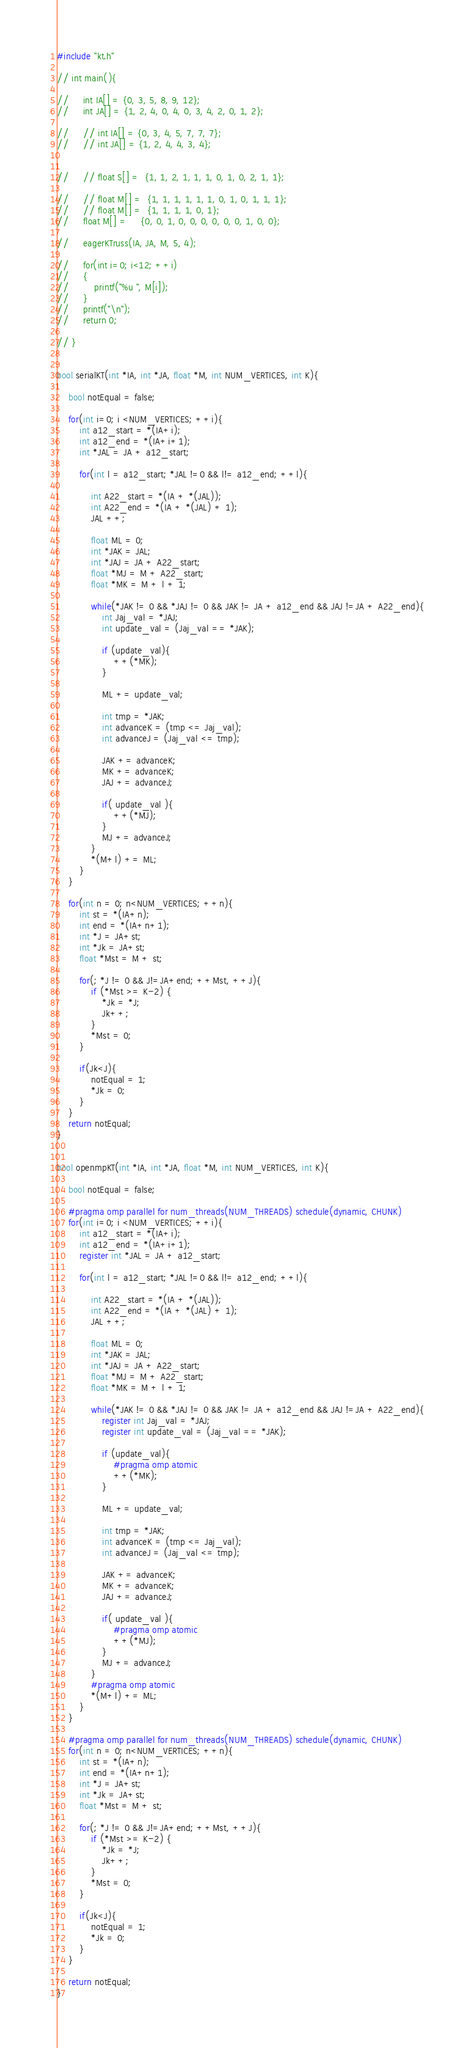Convert code to text. <code><loc_0><loc_0><loc_500><loc_500><_Cuda_>#include "kt.h"

// int main(){

//     int IA[] = {0, 3, 5, 8, 9, 12};
//     int JA[] = {1, 2, 4, 0, 4, 0, 3, 4, 2, 0, 1, 2};

//     // int IA[] = {0, 3, 4, 5, 7, 7, 7};
//     // int JA[] = {1, 2, 4, 4, 3, 4};


//     // float S[] =  {1, 1, 2, 1, 1, 1, 0, 1, 0, 2, 1, 1};

//     // float M[] =  {1, 1, 1, 1, 1, 1, 0, 1, 0, 1, 1, 1};
//     // float M[] =  {1, 1, 1, 1, 0, 1};
//     float M[] =     {0, 0, 1, 0, 0, 0, 0, 0, 0, 1, 0, 0};

//     eagerKTruss(IA, JA, M, 5, 4);

//     for(int i=0; i<12; ++i)
//     {
//         printf("%u ", M[i]);
//     }
//     printf("\n");
//     return 0;

// }


bool serialKT(int *IA, int *JA, float *M, int NUM_VERTICES, int K){

    bool notEqual = false;

    for(int i=0; i <NUM_VERTICES; ++i){
        int a12_start = *(IA+i);
        int a12_end = *(IA+i+1);
        int *JAL = JA + a12_start;

        for(int l = a12_start; *JAL !=0 && l!= a12_end; ++l){

            int A22_start = *(IA + *(JAL));
            int A22_end = *(IA + *(JAL) + 1);
            JAL ++;

            float ML = 0;
            int *JAK = JAL;
            int *JAJ = JA + A22_start;
            float *MJ = M + A22_start;
            float *MK = M + l + 1;

            while(*JAK != 0 && *JAJ != 0 && JAK != JA + a12_end && JAJ !=JA + A22_end){
                int Jaj_val = *JAJ;
                int update_val = (Jaj_val == *JAK);

                if (update_val){
                    ++(*MK);
                }

                ML += update_val;

                int tmp = *JAK;
                int advanceK = (tmp <= Jaj_val);
                int advanceJ = (Jaj_val <= tmp);

                JAK += advanceK;
                MK += advanceK;
                JAJ += advanceJ;

                if( update_val ){
                    ++(*MJ);
                }
                MJ += advanceJ;
            }
            *(M+l) += ML;
        }
    }

    for(int n = 0; n<NUM_VERTICES; ++n){
        int st = *(IA+n);
        int end = *(IA+n+1);
        int *J = JA+st;
        int *Jk = JA+st;
        float *Mst = M + st;

        for(; *J != 0 && J!=JA+end; ++Mst, ++J){
            if (*Mst >= K-2) {
                *Jk = *J;
                Jk++;
            }
            *Mst = 0;
        }

        if(Jk<J){
            notEqual = 1;
            *Jk = 0;
        }
    }
    return notEqual;
}


bool openmpKT(int *IA, int *JA, float *M, int NUM_VERTICES, int K){

    bool notEqual = false;

    #pragma omp parallel for num_threads(NUM_THREADS) schedule(dynamic, CHUNK)
    for(int i=0; i <NUM_VERTICES; ++i){
        int a12_start = *(IA+i);
        int a12_end = *(IA+i+1);
        register int *JAL = JA + a12_start;

        for(int l = a12_start; *JAL !=0 && l!= a12_end; ++l){

            int A22_start = *(IA + *(JAL));
            int A22_end = *(IA + *(JAL) + 1);
            JAL ++;

            float ML = 0;
            int *JAK = JAL;
            int *JAJ = JA + A22_start;
            float *MJ = M + A22_start;
            float *MK = M + l + 1;

            while(*JAK != 0 && *JAJ != 0 && JAK != JA + a12_end && JAJ !=JA + A22_end){
                register int Jaj_val = *JAJ;
                register int update_val = (Jaj_val == *JAK);

                if (update_val){
                    #pragma omp atomic
                    ++(*MK);
                }

                ML += update_val;

                int tmp = *JAK;
                int advanceK = (tmp <= Jaj_val);
                int advanceJ = (Jaj_val <= tmp);

                JAK += advanceK;
                MK += advanceK;
                JAJ += advanceJ;

                if( update_val ){
                    #pragma omp atomic
                    ++(*MJ);
                }
                MJ += advanceJ;
            }
            #pragma omp atomic
            *(M+l) += ML;
        }
    }

    #pragma omp parallel for num_threads(NUM_THREADS) schedule(dynamic, CHUNK)
    for(int n = 0; n<NUM_VERTICES; ++n){
        int st = *(IA+n);
        int end = *(IA+n+1);
        int *J = JA+st;
        int *Jk = JA+st;
        float *Mst = M + st;

        for(; *J != 0 && J!=JA+end; ++Mst, ++J){
            if (*Mst >= K-2) {
                *Jk = *J;
                Jk++;
            }
            *Mst = 0;
        }

        if(Jk<J){
            notEqual = 1;
            *Jk = 0;
        }
    }

    return notEqual;
}
</code> 